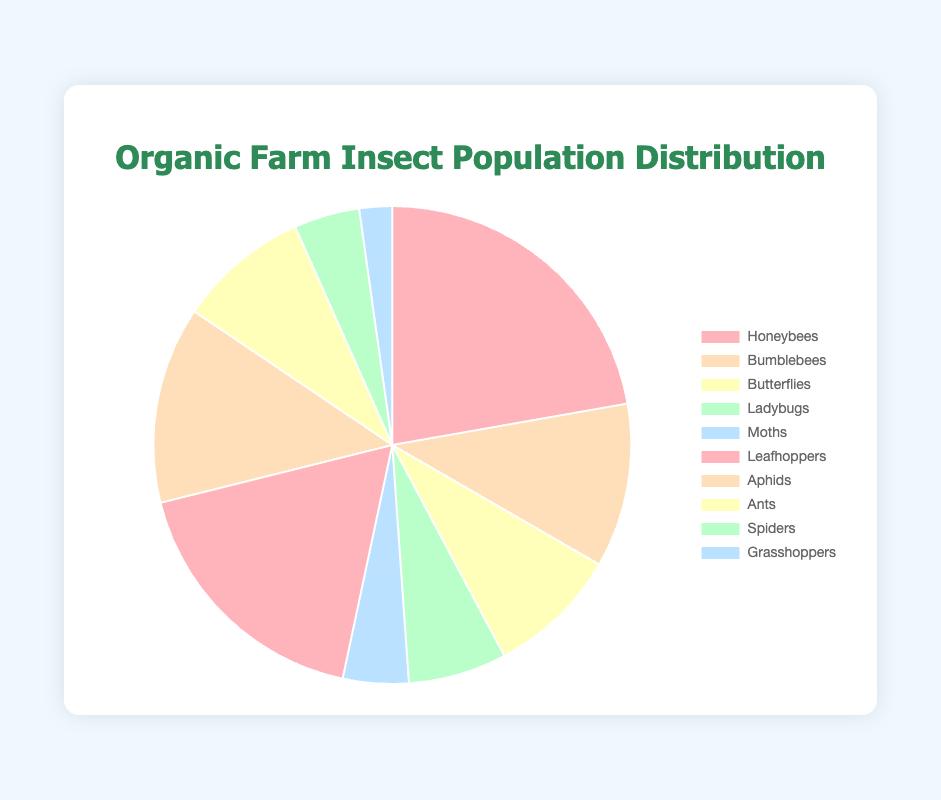What percentage of the insect population are pollinators? The insect types categorized as pollinators are Honeybees, Bumblebees, Butterflies, Ladybugs, and Moths. Their population counts add up to 500 + 250 + 200 + 150 + 100 = 1200. The total insect population is 1200 + 400 + 300 + 200 + 100 + 50 = 2250. Therefore, the percentage = (1200 / 2250) * 100 = 53.33%
Answer: 53.33% Which is the most common insect type in the organic farm? By examining the chart, the sector with the largest size corresponds to the insect type with the highest population count. Honeybees have the largest sector, indicating a population count of 500.
Answer: Honeybees What is the percentage difference between Honeybees and Leafhoppers? The population count for Honeybees is 500, and for Leafhoppers, it is 400. The percentage difference formula = ((500 - 400) / 400) * 100 = (100 / 400) * 100 = 25%.
Answer: 25% How many more pollinators are there compared to non-pollinators? The total population count for pollinators is 1200 and for non-pollinators is 1050. Difference = 1200 - 1050 = 150.
Answer: 150 Which insect type has the smallest population, and what percentage does it represent of the total population? The insect type with the smallest population is Grasshoppers with a count of 50. The total insect population is 2250. Percentage = (50 / 2250) * 100 = 2.22%.
Answer: Grasshoppers, 2.22% Compare the populations of Bumblebees and Ants. Which one is greater and by how much? Bumblebees have a population of 250, and Ants have a population of 200. Difference = 250 - 200 = 50.
Answer: Bumblebees, 50 What proportion of the total insect population are non-pollinators? The total non-pollinator population is 1050 out of a total insect population of 2250. The proportion is 1050 / 2250 = 0.4667, which can be expressed as a percentage of 46.67%.
Answer: 46.67% If the population of Ladybugs doubled, what would be the new proportion of pollinators? The current Ladybug population is 150. Doubling it makes it 300. The new total population of pollinators = 1200 - 150 + 300 = 1350. Total insect population = 2250 - 150 + 300 = 2400. New proportion = 1350 / 2400 = 0.5625 or 56.25%.
Answer: 56.25% How does the population count of Aphids compare to Spiders? Aphids have a population count of 300, whereas Spiders have a count of 100. The difference is 300 - 100 = 200. Aphids have 200 more individuals than Spiders.
Answer: 200 more 